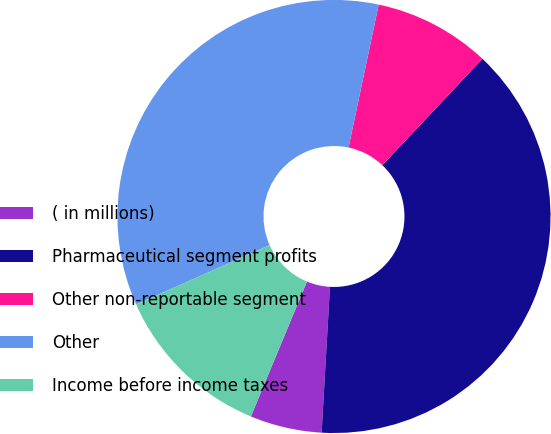<chart> <loc_0><loc_0><loc_500><loc_500><pie_chart><fcel>( in millions)<fcel>Pharmaceutical segment profits<fcel>Other non-reportable segment<fcel>Other<fcel>Income before income taxes<nl><fcel>5.36%<fcel>38.89%<fcel>8.71%<fcel>34.97%<fcel>12.07%<nl></chart> 